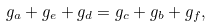Convert formula to latex. <formula><loc_0><loc_0><loc_500><loc_500>g _ { a } + g _ { e } + g _ { d } = g _ { c } + g _ { b } + g _ { f } ,</formula> 